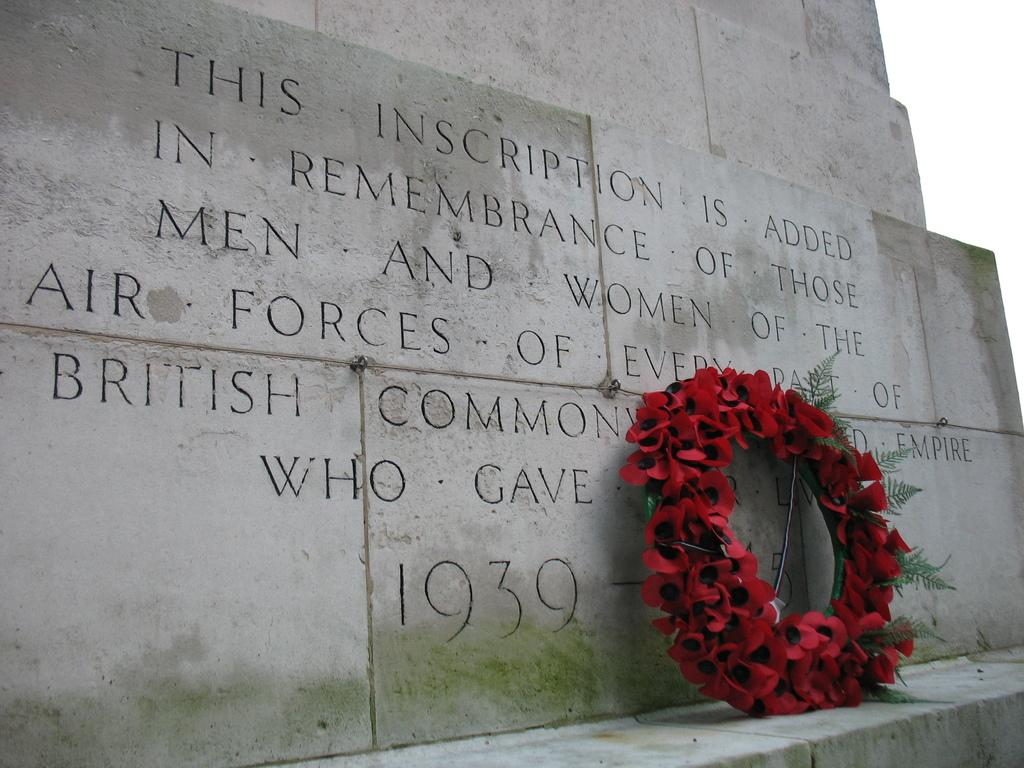What type of flowers are in the bouquet in the image? There is a bouquet of roses in the image. Where is the bouquet located in the image? The bouquet is in the front of the image. What can be seen on the wall in the background of the image? There is text on the wall in the background of the image. How would you describe the weather based on the sky in the image? The sky is cloudy in the image, suggesting a potentially overcast or rainy day. What is the income of the person who ploughed the field in the image? There is no field or person ploughing in the image; it features a bouquet of roses, a wall with text, and a cloudy sky. 